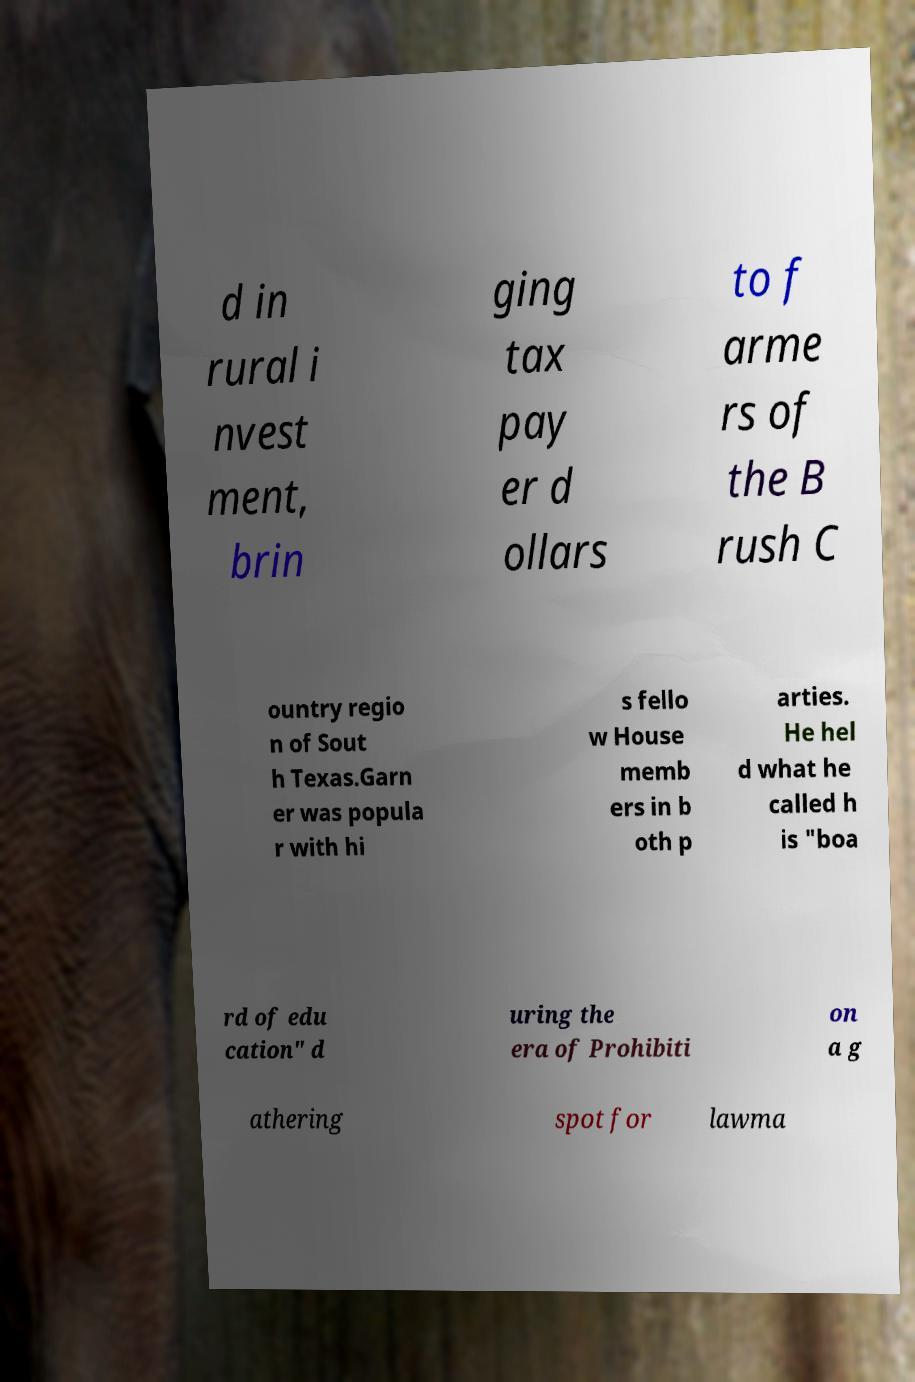Could you extract and type out the text from this image? d in rural i nvest ment, brin ging tax pay er d ollars to f arme rs of the B rush C ountry regio n of Sout h Texas.Garn er was popula r with hi s fello w House memb ers in b oth p arties. He hel d what he called h is "boa rd of edu cation" d uring the era of Prohibiti on a g athering spot for lawma 